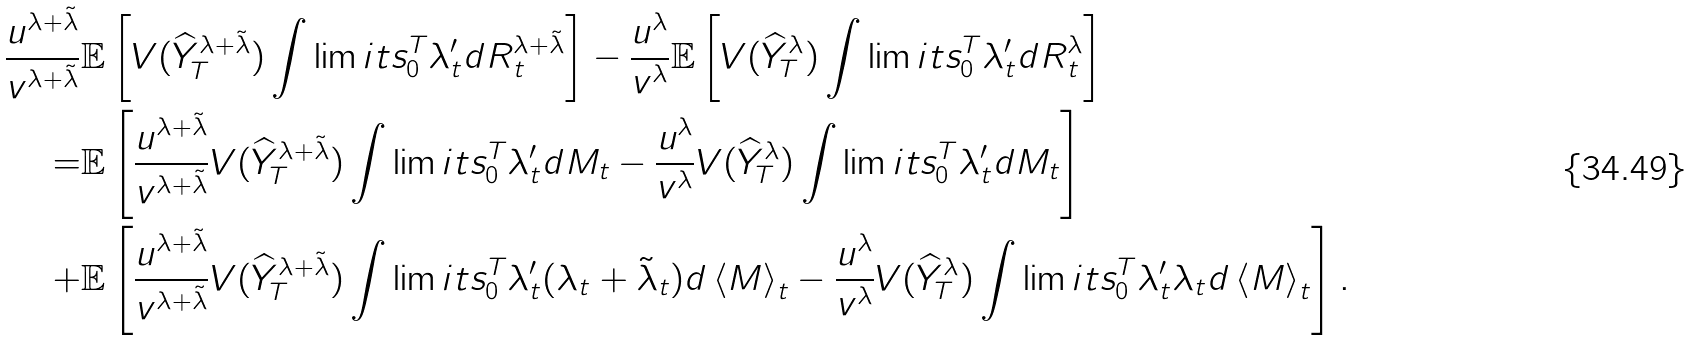Convert formula to latex. <formula><loc_0><loc_0><loc_500><loc_500>\frac { u ^ { \lambda + \tilde { \lambda } } } { v ^ { \lambda + \tilde { \lambda } } } & \mathbb { E } \left [ V ( \widehat { Y } ^ { \lambda + \tilde { \lambda } } _ { T } ) \int \lim i t s _ { 0 } ^ { T } { \lambda _ { t } ^ { \prime } d R ^ { \lambda + \tilde { \lambda } } _ { t } } \right ] - \frac { u ^ { \lambda } } { v ^ { \lambda } } \mathbb { E } \left [ V ( \widehat { Y } ^ { \lambda } _ { T } ) \int \lim i t s _ { 0 } ^ { T } { \lambda _ { t } ^ { \prime } d R ^ { \lambda } _ { t } } \right ] \\ = & \mathbb { E } \left [ \frac { u ^ { \lambda + \tilde { \lambda } } } { v ^ { \lambda + \tilde { \lambda } } } V ( \widehat { Y } ^ { \lambda + \tilde { \lambda } } _ { T } ) \int \lim i t s _ { 0 } ^ { T } { \lambda _ { t } ^ { \prime } d M _ { t } } - \frac { u ^ { \lambda } } { v ^ { \lambda } } V ( \widehat { Y } ^ { \lambda } _ { T } ) \int \lim i t s _ { 0 } ^ { T } { \lambda _ { t } ^ { \prime } d M _ { t } } \right ] \\ + & \mathbb { E } \left [ \frac { u ^ { \lambda + \tilde { \lambda } } } { v ^ { \lambda + \tilde { \lambda } } } V ( \widehat { Y } ^ { \lambda + \tilde { \lambda } } _ { T } ) \int \lim i t s _ { 0 } ^ { T } { \lambda _ { t } ^ { \prime } ( \lambda _ { t } + \tilde { \lambda } _ { t } ) d \left \langle M \right \rangle _ { t } } - \frac { u ^ { \lambda } } { v ^ { \lambda } } V ( \widehat { Y } ^ { \lambda } _ { T } ) \int \lim i t s _ { 0 } ^ { T } { \lambda _ { t } ^ { \prime } \lambda _ { t } d \left \langle M \right \rangle _ { t } } \right ] .</formula> 